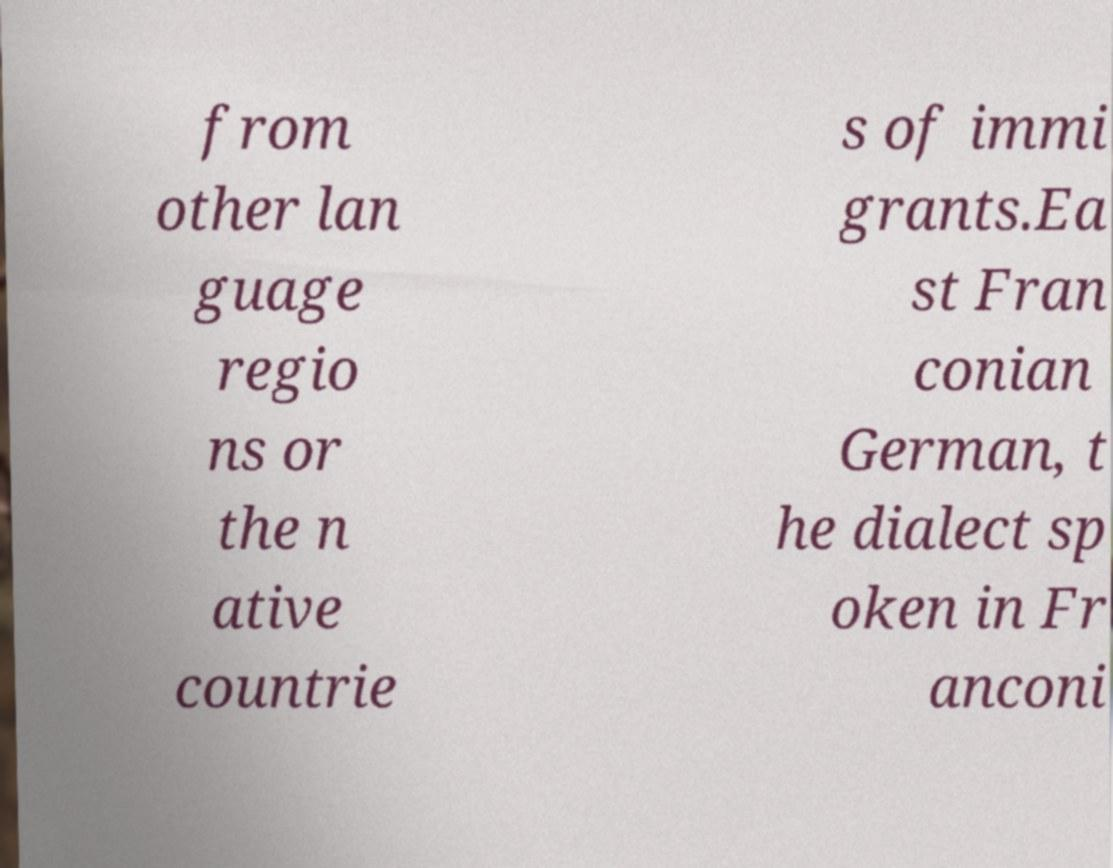Please identify and transcribe the text found in this image. from other lan guage regio ns or the n ative countrie s of immi grants.Ea st Fran conian German, t he dialect sp oken in Fr anconi 